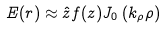Convert formula to latex. <formula><loc_0><loc_0><loc_500><loc_500>E ( r ) \approx \hat { z } f ( z ) J _ { 0 } \left ( k _ { \rho } \rho \right )</formula> 